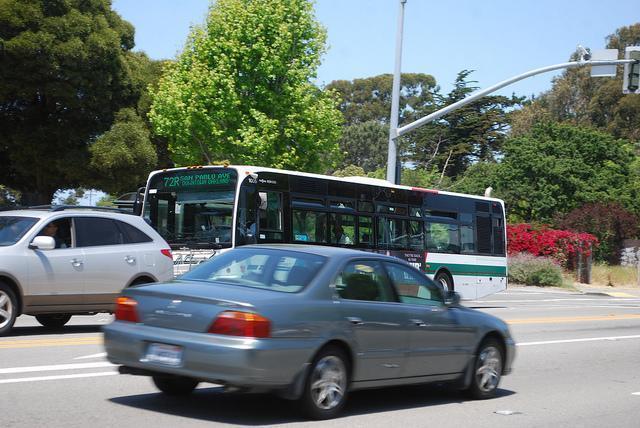How many directions are the vehicles shown going in?
Select the accurate answer and provide explanation: 'Answer: answer
Rationale: rationale.'
Options: Seven, one, three, two. Answer: two.
Rationale: There are two directions. 